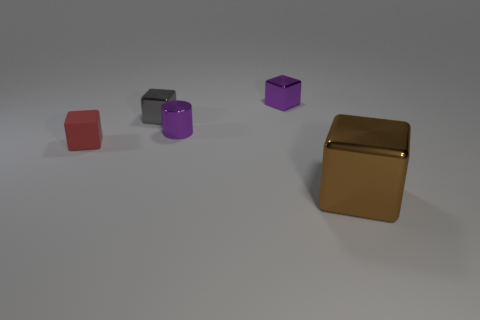There is a metal block that is the same color as the tiny cylinder; what size is it?
Offer a very short reply. Small. Is there anything else that has the same material as the red block?
Your answer should be very brief. No. What is the shape of the gray object that is made of the same material as the cylinder?
Your answer should be compact. Cube. How many large objects are red matte objects or green blocks?
Your answer should be compact. 0. Is there a big metallic cube that is behind the block that is on the right side of the purple cube?
Provide a short and direct response. No. Are there any big cyan metal cubes?
Give a very brief answer. No. What is the color of the tiny block that is in front of the small gray block behind the small purple metal cylinder?
Keep it short and to the point. Red. What material is the small red thing that is the same shape as the gray object?
Your response must be concise. Rubber. How many gray metallic cubes have the same size as the metal cylinder?
Your answer should be very brief. 1. There is a gray block that is the same material as the brown thing; what size is it?
Keep it short and to the point. Small. 